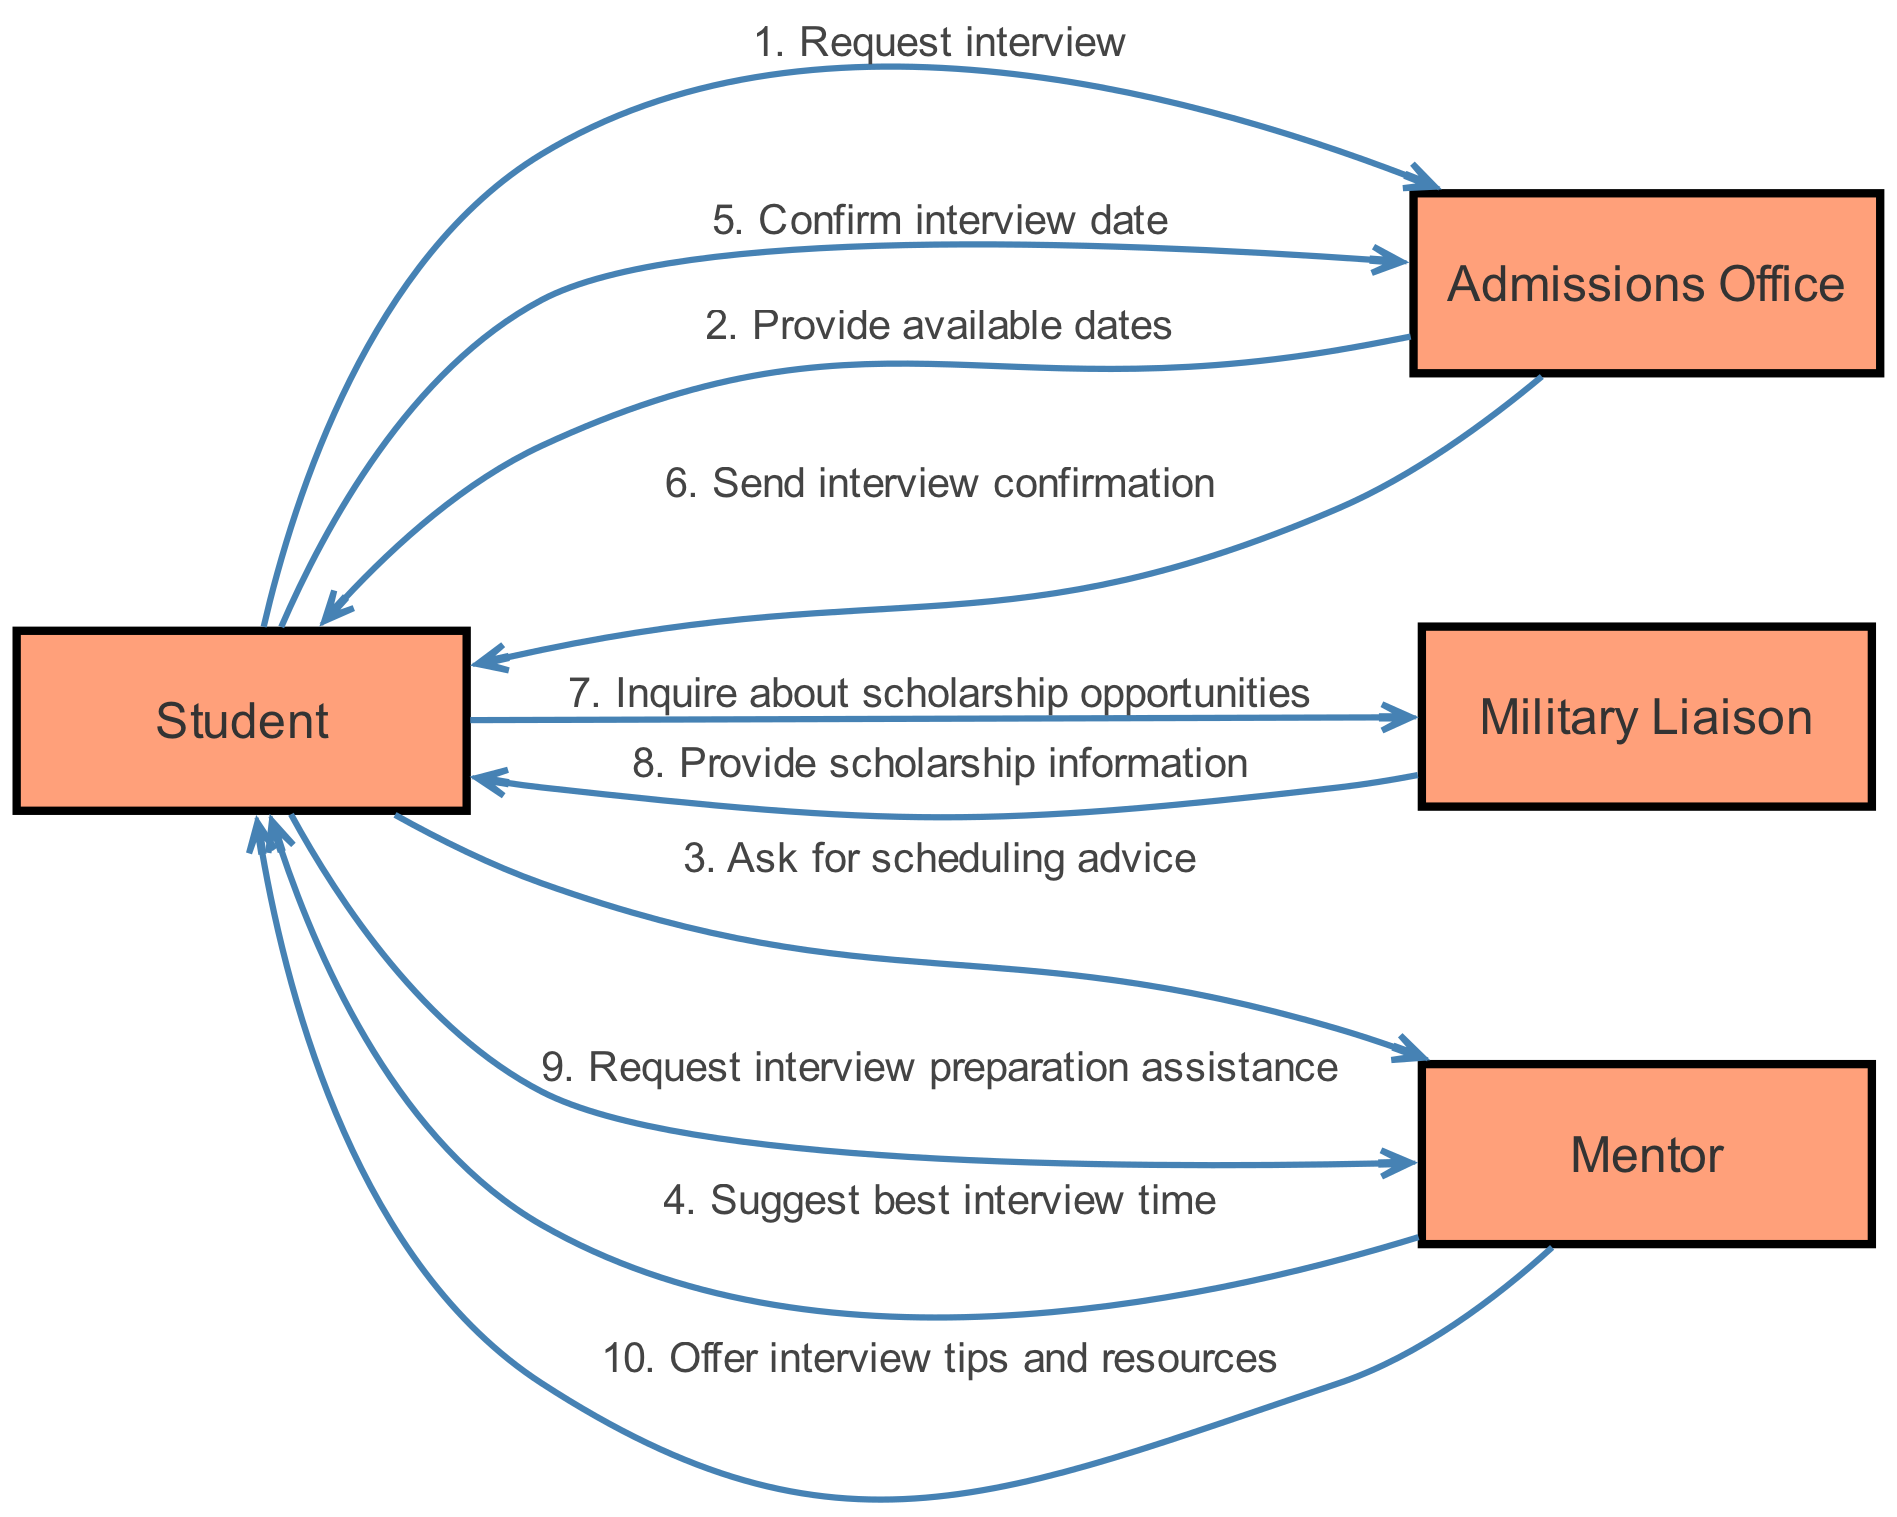What is the first action taken in the sequence? The first action in the sequence is initiated by the Student, who sends a "Request interview" to the Admissions Office. This is the starting point of the interaction.
Answer: Request interview How many actors are involved in the diagram? The diagram shows a total of four actors participating in the sequence: Student, Admissions Office, Military Liaison, and Mentor. Each actor represents a different role in the process.
Answer: Four What message does the Military Liaison send to the Student? The Military Liaison sends the message "Provide scholarship information" to the Student, indicating the support offered regarding scholarship opportunities.
Answer: Provide scholarship information Which actor suggests the best interview time? The Mentor is the actor who suggests the best interview time to the Student after the Student seeks scheduling advice. This highlights the Mentor's role in advising the Student.
Answer: Mentor How many total messages are exchanged in the diagram? There are a total of ten messages exchanged among the actors in the sequence. Each interaction adds up to reflect the full communication process occurring within the sequence.
Answer: Ten What is the final confirmation action in the sequence? The final confirmation action is that the Admissions Office sends an "interview confirmation" to the Student, which signifies that the interview has been successfully scheduled.
Answer: Send interview confirmation What two roles does the Student engage with consecutively after confirming the interview? After confirming the interview with the Admissions Office, the Student first inquires about scholarship opportunities with the Military Liaison and then requests interview preparation assistance from the Mentor, indicating ongoing support needs.
Answer: Military Liaison and Mentor Describe the flow of communication after the Student requests interview preparation assistance. After the Student requests interview preparation assistance, the Mentor replies by offering "interview tips and resources," completing the communication loop regarding interview preparation. This shows the sequence of support provided by the Mentor.
Answer: Mentor offers interview tips and resources 